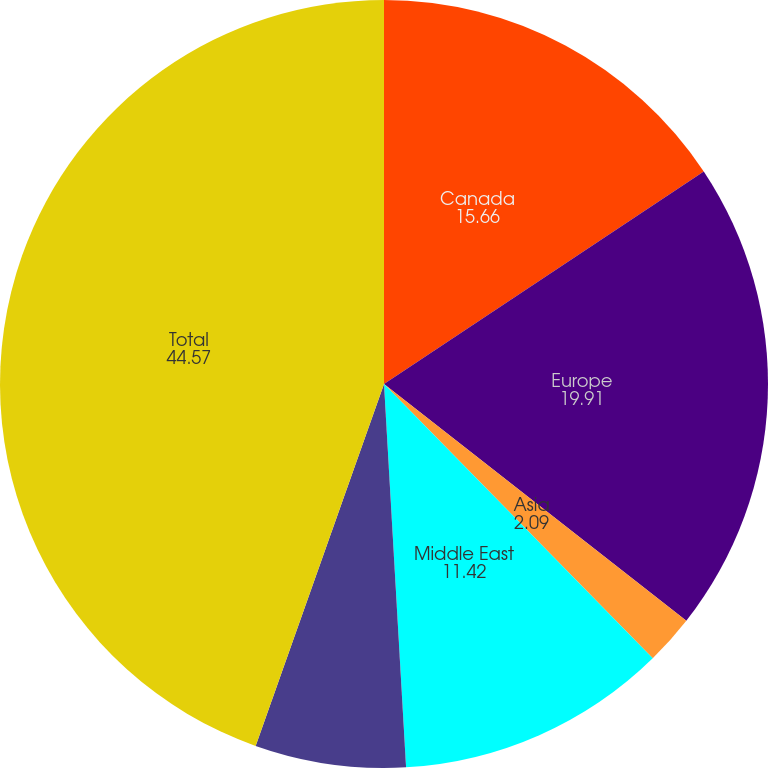Convert chart. <chart><loc_0><loc_0><loc_500><loc_500><pie_chart><fcel>Canada<fcel>Europe<fcel>Asia<fcel>Middle East<fcel>Rest of the world<fcel>Total<nl><fcel>15.66%<fcel>19.91%<fcel>2.09%<fcel>11.42%<fcel>6.34%<fcel>44.57%<nl></chart> 